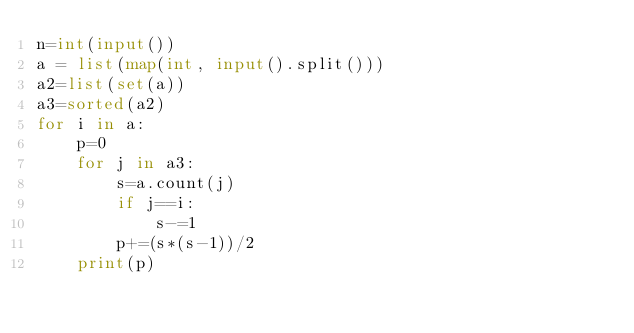<code> <loc_0><loc_0><loc_500><loc_500><_Python_>n=int(input())
a = list(map(int, input().split()))
a2=list(set(a))
a3=sorted(a2)
for i in a:
    p=0
    for j in a3:
        s=a.count(j)
        if j==i:
            s-=1
        p+=(s*(s-1))/2
    print(p)</code> 